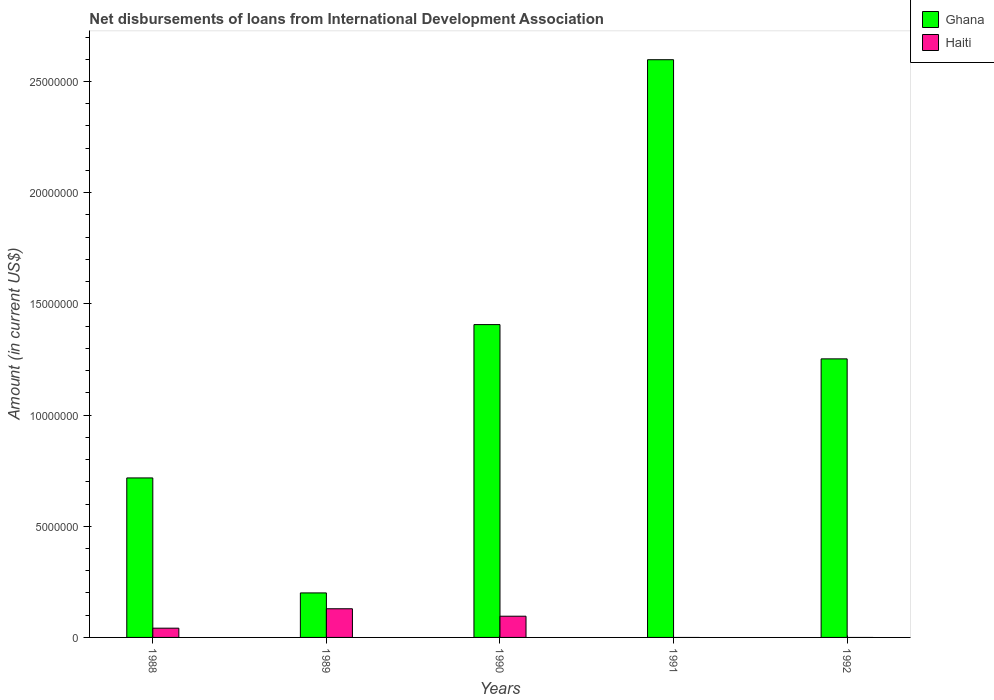Are the number of bars per tick equal to the number of legend labels?
Your answer should be very brief. No. Are the number of bars on each tick of the X-axis equal?
Your answer should be very brief. No. What is the label of the 2nd group of bars from the left?
Offer a terse response. 1989. In how many cases, is the number of bars for a given year not equal to the number of legend labels?
Provide a succinct answer. 2. What is the amount of loans disbursed in Haiti in 1989?
Your response must be concise. 1.29e+06. Across all years, what is the maximum amount of loans disbursed in Ghana?
Keep it short and to the point. 2.60e+07. Across all years, what is the minimum amount of loans disbursed in Ghana?
Your answer should be compact. 2.00e+06. In which year was the amount of loans disbursed in Haiti maximum?
Your answer should be compact. 1989. What is the total amount of loans disbursed in Ghana in the graph?
Offer a terse response. 6.18e+07. What is the difference between the amount of loans disbursed in Ghana in 1988 and that in 1989?
Give a very brief answer. 5.17e+06. What is the difference between the amount of loans disbursed in Haiti in 1991 and the amount of loans disbursed in Ghana in 1990?
Provide a succinct answer. -1.41e+07. What is the average amount of loans disbursed in Haiti per year?
Offer a very short reply. 5.32e+05. In the year 1990, what is the difference between the amount of loans disbursed in Haiti and amount of loans disbursed in Ghana?
Offer a very short reply. -1.31e+07. In how many years, is the amount of loans disbursed in Haiti greater than 20000000 US$?
Provide a short and direct response. 0. What is the ratio of the amount of loans disbursed in Ghana in 1988 to that in 1991?
Offer a terse response. 0.28. Is the difference between the amount of loans disbursed in Haiti in 1989 and 1990 greater than the difference between the amount of loans disbursed in Ghana in 1989 and 1990?
Provide a short and direct response. Yes. What is the difference between the highest and the second highest amount of loans disbursed in Ghana?
Make the answer very short. 1.19e+07. What is the difference between the highest and the lowest amount of loans disbursed in Haiti?
Give a very brief answer. 1.29e+06. What is the difference between two consecutive major ticks on the Y-axis?
Provide a succinct answer. 5.00e+06. Are the values on the major ticks of Y-axis written in scientific E-notation?
Give a very brief answer. No. Does the graph contain grids?
Offer a very short reply. No. What is the title of the graph?
Your answer should be very brief. Net disbursements of loans from International Development Association. What is the Amount (in current US$) in Ghana in 1988?
Offer a very short reply. 7.17e+06. What is the Amount (in current US$) in Haiti in 1988?
Make the answer very short. 4.16e+05. What is the Amount (in current US$) in Ghana in 1989?
Provide a succinct answer. 2.00e+06. What is the Amount (in current US$) of Haiti in 1989?
Offer a terse response. 1.29e+06. What is the Amount (in current US$) of Ghana in 1990?
Provide a succinct answer. 1.41e+07. What is the Amount (in current US$) in Haiti in 1990?
Your response must be concise. 9.54e+05. What is the Amount (in current US$) of Ghana in 1991?
Give a very brief answer. 2.60e+07. What is the Amount (in current US$) in Haiti in 1991?
Provide a succinct answer. 0. What is the Amount (in current US$) in Ghana in 1992?
Offer a very short reply. 1.25e+07. What is the Amount (in current US$) of Haiti in 1992?
Offer a very short reply. 0. Across all years, what is the maximum Amount (in current US$) in Ghana?
Provide a succinct answer. 2.60e+07. Across all years, what is the maximum Amount (in current US$) in Haiti?
Provide a short and direct response. 1.29e+06. Across all years, what is the minimum Amount (in current US$) of Ghana?
Offer a terse response. 2.00e+06. Across all years, what is the minimum Amount (in current US$) in Haiti?
Your response must be concise. 0. What is the total Amount (in current US$) in Ghana in the graph?
Ensure brevity in your answer.  6.18e+07. What is the total Amount (in current US$) of Haiti in the graph?
Offer a terse response. 2.66e+06. What is the difference between the Amount (in current US$) of Ghana in 1988 and that in 1989?
Offer a very short reply. 5.17e+06. What is the difference between the Amount (in current US$) of Haiti in 1988 and that in 1989?
Offer a terse response. -8.73e+05. What is the difference between the Amount (in current US$) in Ghana in 1988 and that in 1990?
Ensure brevity in your answer.  -6.90e+06. What is the difference between the Amount (in current US$) of Haiti in 1988 and that in 1990?
Your response must be concise. -5.38e+05. What is the difference between the Amount (in current US$) in Ghana in 1988 and that in 1991?
Your response must be concise. -1.88e+07. What is the difference between the Amount (in current US$) in Ghana in 1988 and that in 1992?
Offer a very short reply. -5.35e+06. What is the difference between the Amount (in current US$) of Ghana in 1989 and that in 1990?
Give a very brief answer. -1.21e+07. What is the difference between the Amount (in current US$) of Haiti in 1989 and that in 1990?
Your response must be concise. 3.35e+05. What is the difference between the Amount (in current US$) of Ghana in 1989 and that in 1991?
Keep it short and to the point. -2.40e+07. What is the difference between the Amount (in current US$) of Ghana in 1989 and that in 1992?
Offer a terse response. -1.05e+07. What is the difference between the Amount (in current US$) in Ghana in 1990 and that in 1991?
Keep it short and to the point. -1.19e+07. What is the difference between the Amount (in current US$) in Ghana in 1990 and that in 1992?
Make the answer very short. 1.54e+06. What is the difference between the Amount (in current US$) of Ghana in 1991 and that in 1992?
Your answer should be very brief. 1.35e+07. What is the difference between the Amount (in current US$) in Ghana in 1988 and the Amount (in current US$) in Haiti in 1989?
Make the answer very short. 5.88e+06. What is the difference between the Amount (in current US$) in Ghana in 1988 and the Amount (in current US$) in Haiti in 1990?
Provide a short and direct response. 6.22e+06. What is the difference between the Amount (in current US$) of Ghana in 1989 and the Amount (in current US$) of Haiti in 1990?
Your response must be concise. 1.05e+06. What is the average Amount (in current US$) in Ghana per year?
Offer a terse response. 1.24e+07. What is the average Amount (in current US$) of Haiti per year?
Keep it short and to the point. 5.32e+05. In the year 1988, what is the difference between the Amount (in current US$) of Ghana and Amount (in current US$) of Haiti?
Your response must be concise. 6.76e+06. In the year 1989, what is the difference between the Amount (in current US$) of Ghana and Amount (in current US$) of Haiti?
Provide a succinct answer. 7.13e+05. In the year 1990, what is the difference between the Amount (in current US$) in Ghana and Amount (in current US$) in Haiti?
Keep it short and to the point. 1.31e+07. What is the ratio of the Amount (in current US$) of Ghana in 1988 to that in 1989?
Make the answer very short. 3.58. What is the ratio of the Amount (in current US$) in Haiti in 1988 to that in 1989?
Your answer should be very brief. 0.32. What is the ratio of the Amount (in current US$) in Ghana in 1988 to that in 1990?
Provide a short and direct response. 0.51. What is the ratio of the Amount (in current US$) in Haiti in 1988 to that in 1990?
Ensure brevity in your answer.  0.44. What is the ratio of the Amount (in current US$) of Ghana in 1988 to that in 1991?
Ensure brevity in your answer.  0.28. What is the ratio of the Amount (in current US$) in Ghana in 1988 to that in 1992?
Your answer should be very brief. 0.57. What is the ratio of the Amount (in current US$) of Ghana in 1989 to that in 1990?
Ensure brevity in your answer.  0.14. What is the ratio of the Amount (in current US$) in Haiti in 1989 to that in 1990?
Give a very brief answer. 1.35. What is the ratio of the Amount (in current US$) of Ghana in 1989 to that in 1991?
Keep it short and to the point. 0.08. What is the ratio of the Amount (in current US$) in Ghana in 1989 to that in 1992?
Give a very brief answer. 0.16. What is the ratio of the Amount (in current US$) in Ghana in 1990 to that in 1991?
Your response must be concise. 0.54. What is the ratio of the Amount (in current US$) in Ghana in 1990 to that in 1992?
Make the answer very short. 1.12. What is the ratio of the Amount (in current US$) of Ghana in 1991 to that in 1992?
Provide a short and direct response. 2.07. What is the difference between the highest and the second highest Amount (in current US$) of Ghana?
Your answer should be very brief. 1.19e+07. What is the difference between the highest and the second highest Amount (in current US$) of Haiti?
Ensure brevity in your answer.  3.35e+05. What is the difference between the highest and the lowest Amount (in current US$) of Ghana?
Provide a short and direct response. 2.40e+07. What is the difference between the highest and the lowest Amount (in current US$) of Haiti?
Offer a terse response. 1.29e+06. 